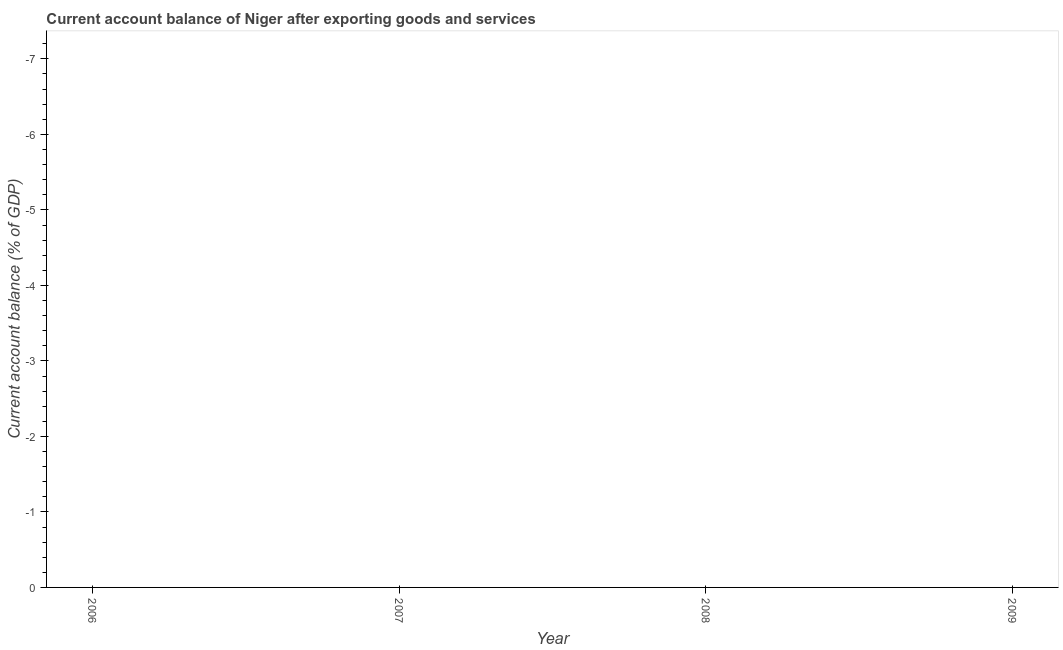Across all years, what is the minimum current account balance?
Make the answer very short. 0. What is the sum of the current account balance?
Your answer should be very brief. 0. What is the average current account balance per year?
Keep it short and to the point. 0. Does the current account balance monotonically increase over the years?
Your answer should be compact. No. How many years are there in the graph?
Your answer should be very brief. 4. Are the values on the major ticks of Y-axis written in scientific E-notation?
Provide a succinct answer. No. Does the graph contain any zero values?
Provide a short and direct response. Yes. What is the title of the graph?
Keep it short and to the point. Current account balance of Niger after exporting goods and services. What is the label or title of the X-axis?
Ensure brevity in your answer.  Year. What is the label or title of the Y-axis?
Give a very brief answer. Current account balance (% of GDP). What is the Current account balance (% of GDP) of 2008?
Your answer should be compact. 0. What is the Current account balance (% of GDP) in 2009?
Offer a terse response. 0. 